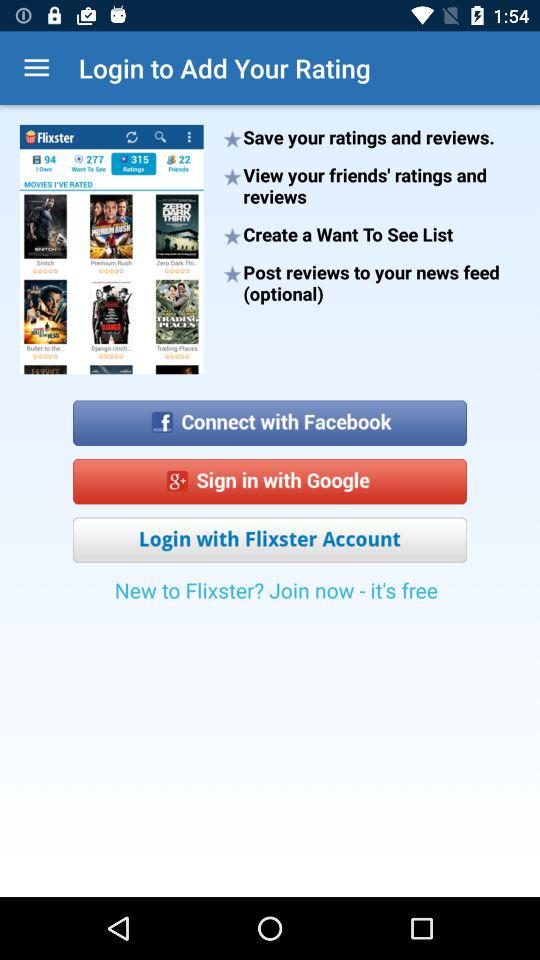How can we connect? You can connect through Facebook. 